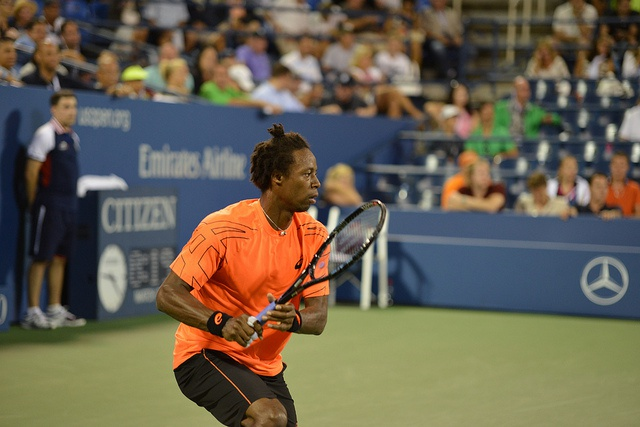Describe the objects in this image and their specific colors. I can see people in black, olive, gray, and maroon tones, people in black, red, and maroon tones, people in black, gray, olive, and darkgray tones, tennis racket in black, gray, darkgray, and salmon tones, and chair in black, darkgray, gray, and beige tones in this image. 